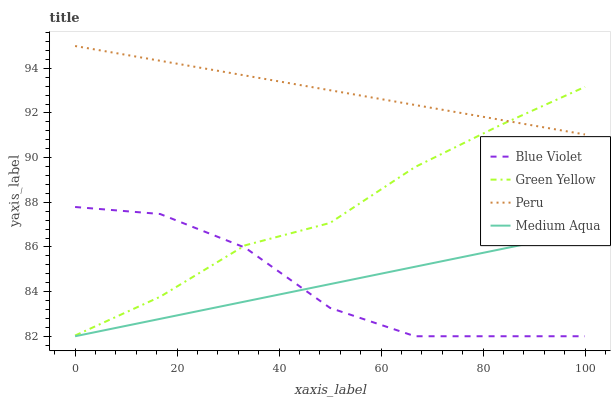Does Blue Violet have the minimum area under the curve?
Answer yes or no. Yes. Does Peru have the maximum area under the curve?
Answer yes or no. Yes. Does Medium Aqua have the minimum area under the curve?
Answer yes or no. No. Does Medium Aqua have the maximum area under the curve?
Answer yes or no. No. Is Medium Aqua the smoothest?
Answer yes or no. Yes. Is Blue Violet the roughest?
Answer yes or no. Yes. Is Peru the smoothest?
Answer yes or no. No. Is Peru the roughest?
Answer yes or no. No. Does Medium Aqua have the lowest value?
Answer yes or no. Yes. Does Peru have the lowest value?
Answer yes or no. No. Does Peru have the highest value?
Answer yes or no. Yes. Does Medium Aqua have the highest value?
Answer yes or no. No. Is Medium Aqua less than Peru?
Answer yes or no. Yes. Is Green Yellow greater than Medium Aqua?
Answer yes or no. Yes. Does Green Yellow intersect Blue Violet?
Answer yes or no. Yes. Is Green Yellow less than Blue Violet?
Answer yes or no. No. Is Green Yellow greater than Blue Violet?
Answer yes or no. No. Does Medium Aqua intersect Peru?
Answer yes or no. No. 